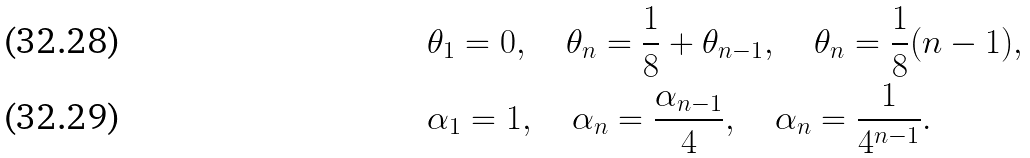Convert formula to latex. <formula><loc_0><loc_0><loc_500><loc_500>& \theta _ { 1 } = 0 , \quad \theta _ { n } = \frac { 1 } { 8 } + \theta _ { n - 1 } , \quad \theta _ { n } = \frac { 1 } { 8 } ( n - 1 ) , \\ & \alpha _ { 1 } = 1 , \quad \alpha _ { n } = \frac { \alpha _ { n - 1 } } { 4 } , \quad \alpha _ { n } = \frac { 1 } { 4 ^ { n - 1 } } .</formula> 